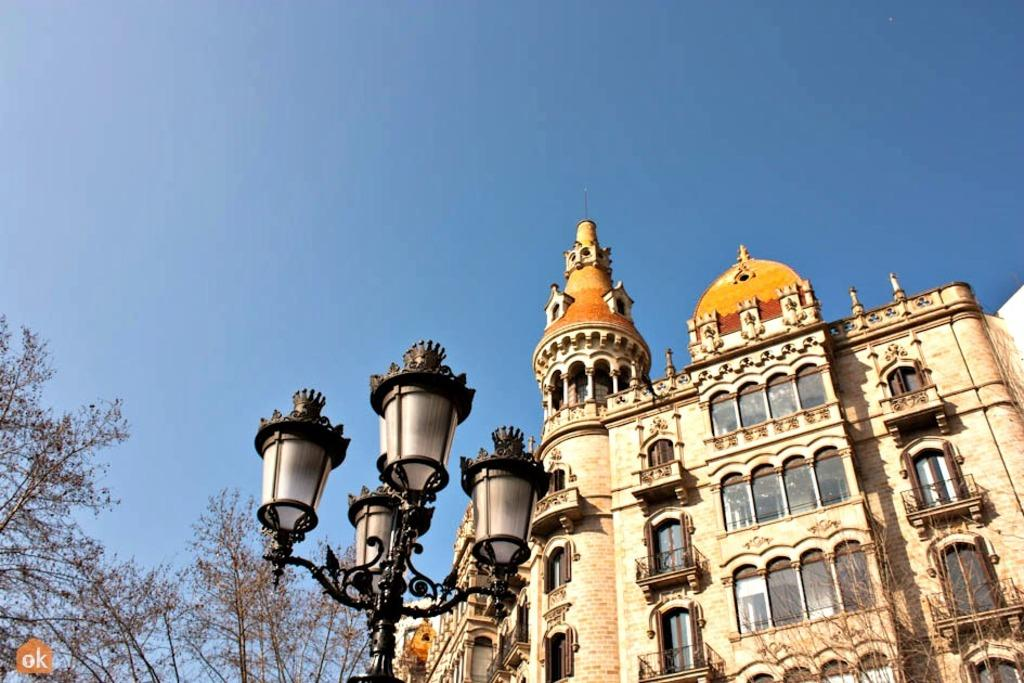What type of structures can be seen in the image? There are buildings in the image. What other natural elements are present in the image? There are trees in the image. What type of lighting is present in the image? There are street lamps in the image. What is visible at the top of the image? The sky is visible at the top of the image. What type of lunch is being served in the image? There is no lunch present in the image; it features buildings, trees, street lamps, and the sky. What title is given to the image? The provided facts do not mention a title for the image. 